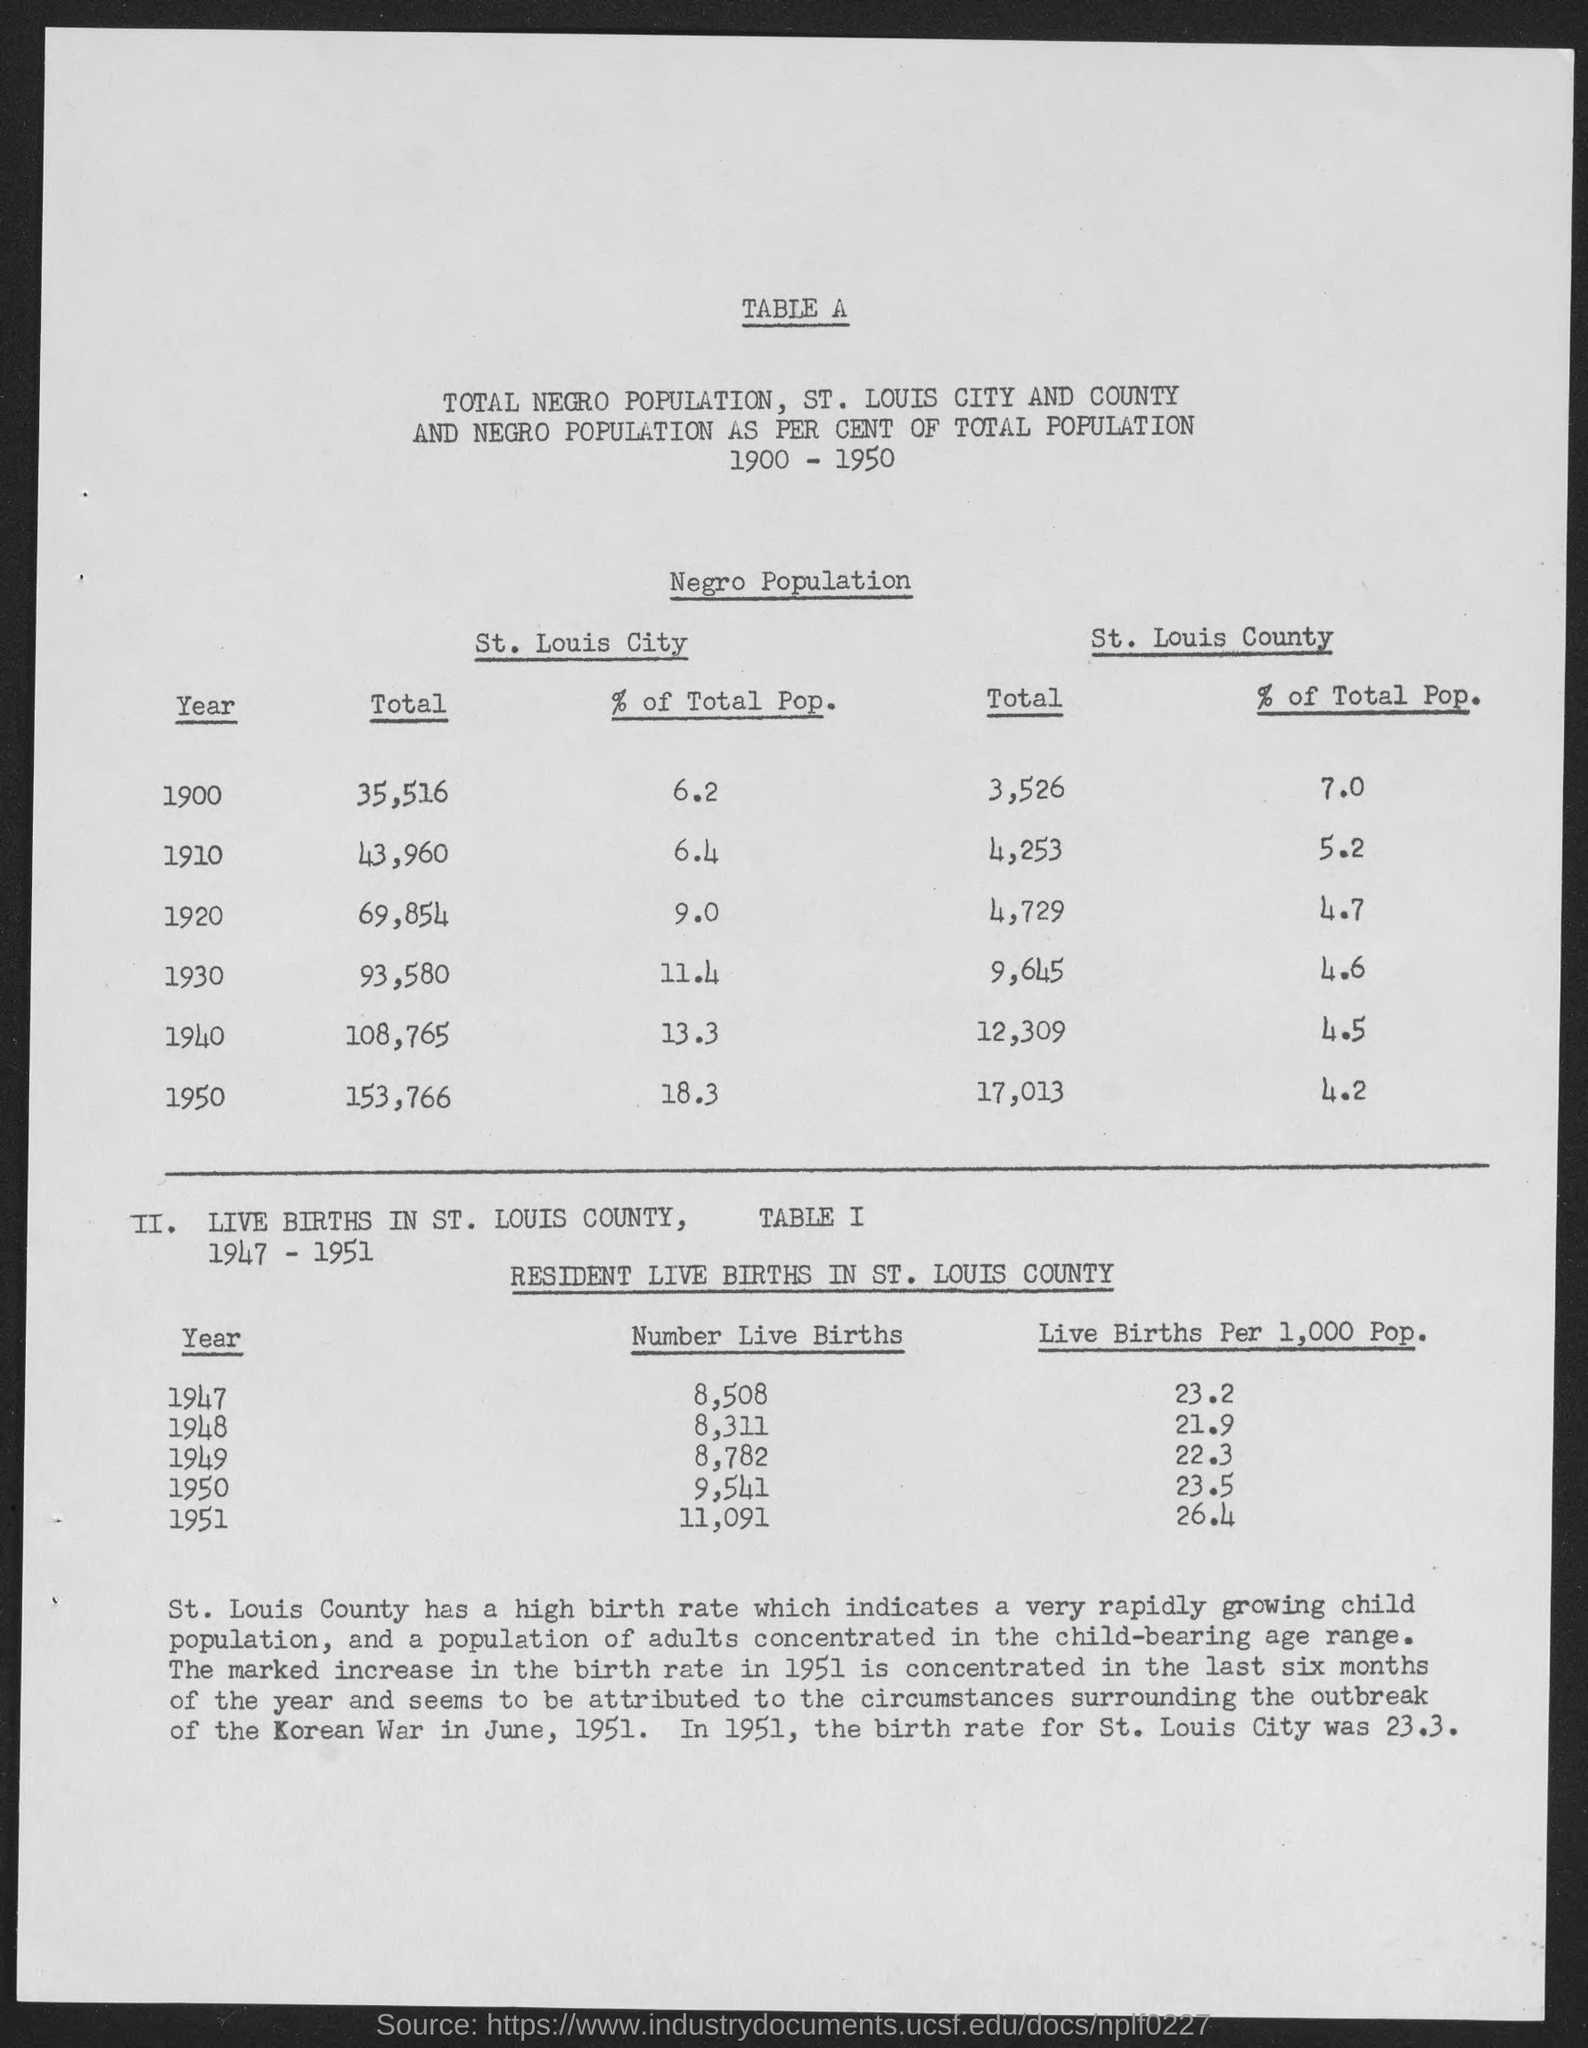What is the Total in St. Louis City for year 1900?
Offer a very short reply. 35,516. What is the Total in St. Louis City for year 1910?
Your response must be concise. 43,960. What is the Total in St. Louis City for year 1920?
Provide a succinct answer. 69,854. What is the Total in St. Louis City for year 1930?
Offer a terse response. 93,580. What is the Total in St. Louis City for year 1940?
Offer a very short reply. 108,765. What is the Total in St. Louis City for year 1950?
Provide a short and direct response. 153,766. What is the % of Total Pop. in St. Louis City for year 1900?
Offer a very short reply. 6.2. What is the % of Total Pop. in St. Louis City for year 1910?
Your answer should be very brief. 6.4. What is the % of Total Pop. in St. Louis City for year 1920?
Give a very brief answer. 9.0. What is the % of Total Pop. in St. Louis City for year 1930?
Ensure brevity in your answer.  11.4. 